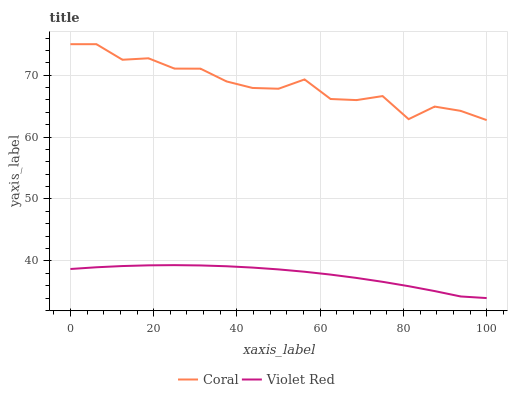Does Violet Red have the minimum area under the curve?
Answer yes or no. Yes. Does Coral have the maximum area under the curve?
Answer yes or no. Yes. Does Violet Red have the maximum area under the curve?
Answer yes or no. No. Is Violet Red the smoothest?
Answer yes or no. Yes. Is Coral the roughest?
Answer yes or no. Yes. Is Violet Red the roughest?
Answer yes or no. No. Does Violet Red have the highest value?
Answer yes or no. No. Is Violet Red less than Coral?
Answer yes or no. Yes. Is Coral greater than Violet Red?
Answer yes or no. Yes. Does Violet Red intersect Coral?
Answer yes or no. No. 